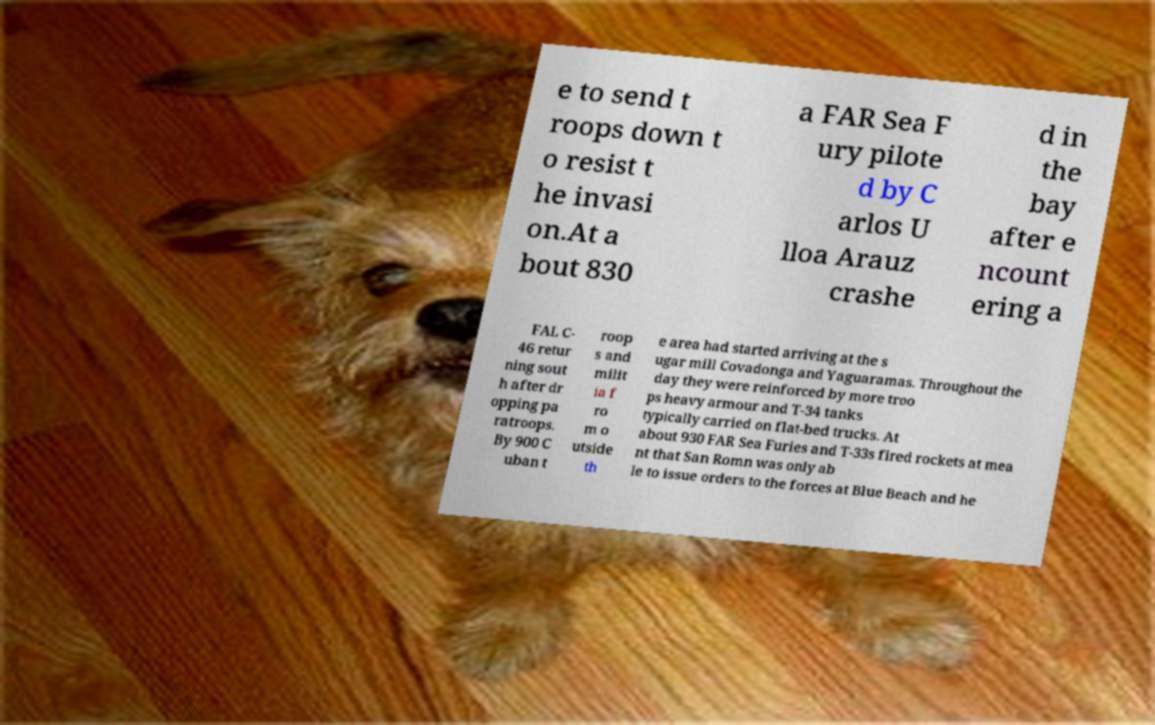Please read and relay the text visible in this image. What does it say? e to send t roops down t o resist t he invasi on.At a bout 830 a FAR Sea F ury pilote d by C arlos U lloa Arauz crashe d in the bay after e ncount ering a FAL C- 46 retur ning sout h after dr opping pa ratroops. By 900 C uban t roop s and milit ia f ro m o utside th e area had started arriving at the s ugar mill Covadonga and Yaguaramas. Throughout the day they were reinforced by more troo ps heavy armour and T-34 tanks typically carried on flat-bed trucks. At about 930 FAR Sea Furies and T-33s fired rockets at mea nt that San Romn was only ab le to issue orders to the forces at Blue Beach and he 